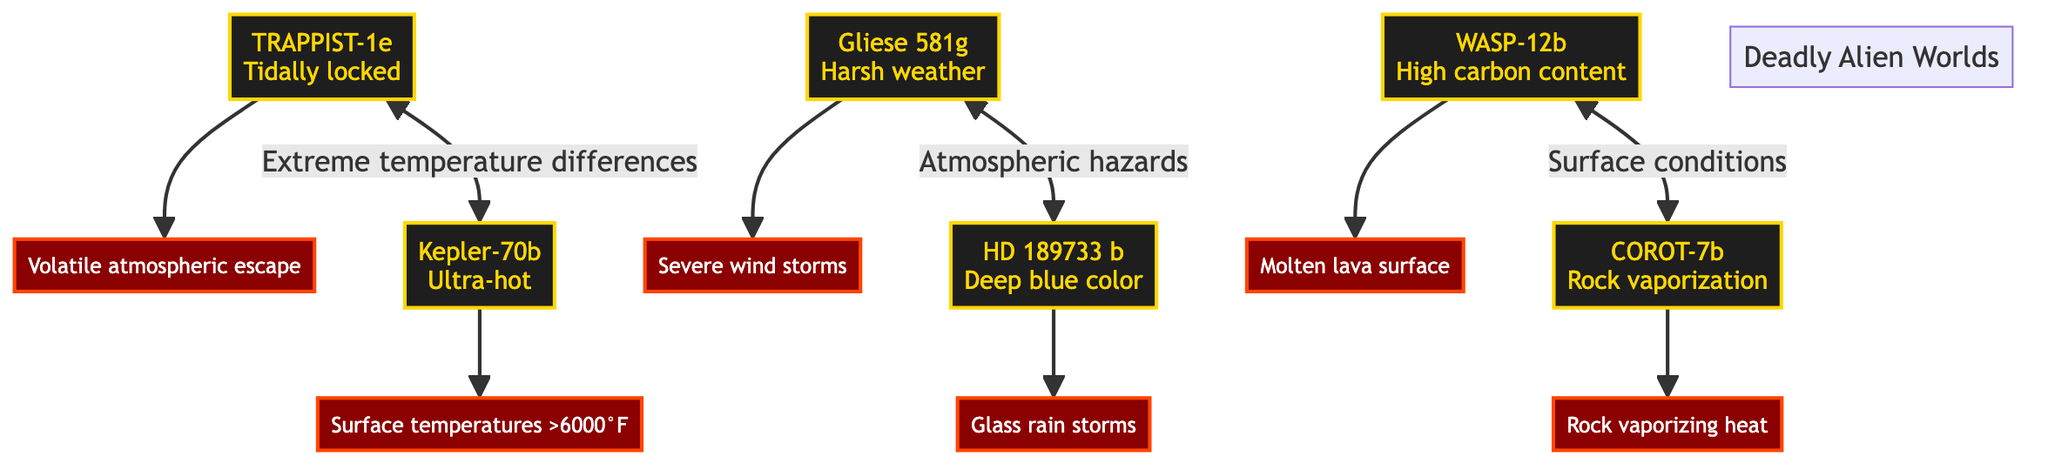What is the surface temperature of Kepler-70b? The diagram states that Kepler-70b has surface temperatures greater than 6000°F, as indicated by its associated hazard.
Answer: Surface temperatures >6000°F Which planet is known for glass rain storms? The diagram connects HD 189733b with its hazard of glass rain storms, making it clear that this planet is known for such conditions.
Answer: Glass rain storms How many planets are illustrated in the diagram? By counting each of the planet nodes in the diagram, we identify a total of six distinct planets, each with its specific hazards.
Answer: 6 What type of hazardous condition is associated with TRAPPIST-1e? The hazard linked to TRAPPIST-1e is volatile atmospheric escape, which is directly connected to this planet in the diagram.
Answer: Volatile atmospheric escape Which two planets are connected by the note "Atmospheric hazards"? The arrows indicate that Gliese 581g and HD 189733b have a connection labeled "Atmospheric hazards," signifying a relationship between their conditions.
Answer: Gliese 581g and HD 189733b Which planet has a molten lava surface? According to the diagram, WASP-12b is the planet labeled with the hazard of molten lava surface, clearly indicating the treacherous condition of this exoplanet.
Answer: Molten lava surface Which planets are connected by the extreme temperature differences? The diagram shows a bidirectional connection between TRAPPIST-1e and Kepler-70b labeled with extreme temperature differences, illustrating their relationship.
Answer: TRAPPIST-1e and Kepler-70b What is the common feature of both WASP-12b and COROT-7b? Both planets are displayed in the diagram with a label indicating specific surface conditions, highlighting their hazardous environments linked with their respective hazards.
Answer: Surface conditions What is the color associated with HD 189733b? The diagram specifies HD 189733b with a descriptor of deep blue color, indicating its visual or atmospheric characteristic.
Answer: Deep blue color 